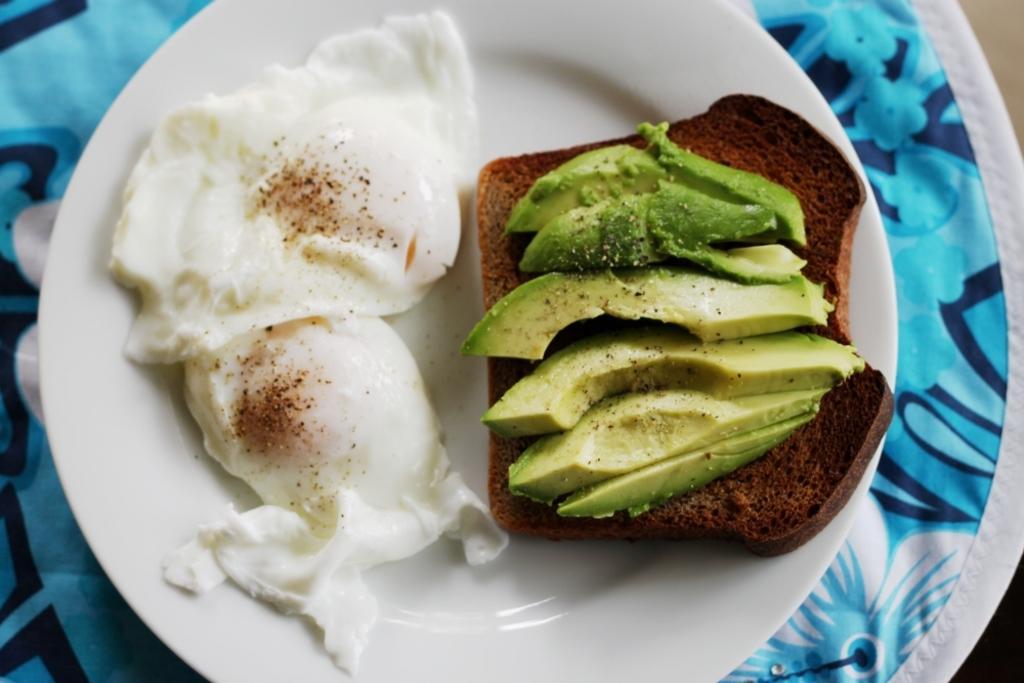Could you give a brief overview of what you see in this image? In this image there is food on the plate which is on the blue colour cloth. 